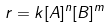<formula> <loc_0><loc_0><loc_500><loc_500>r = k [ A ] ^ { n } [ B ] ^ { m }</formula> 